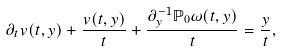Convert formula to latex. <formula><loc_0><loc_0><loc_500><loc_500>\partial _ { t } v ( t , y ) + \frac { v ( t , y ) } { t } + \frac { \partial _ { y } ^ { - 1 } \mathbb { P } _ { 0 } \omega ( t , y ) } { t } = \frac { y } { t } ,</formula> 